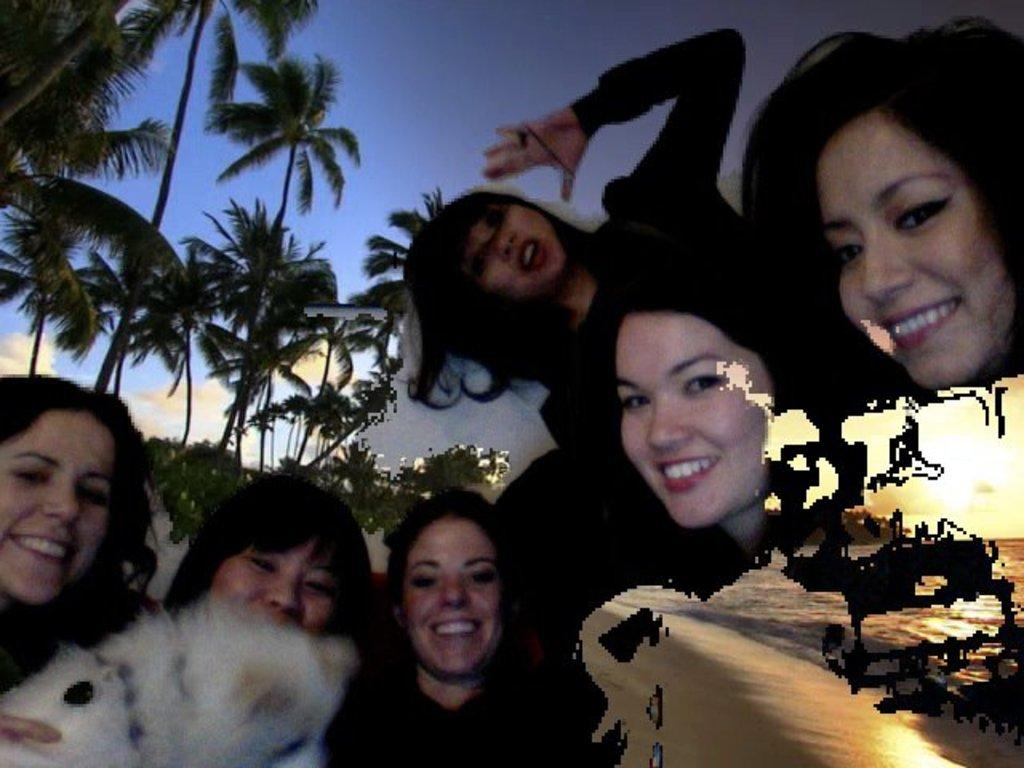What is happening in the image involving the group of people? The people in the image are smiling, suggesting they are enjoying themselves. Can you describe the environment in which the group of people is located? There is water visible at the bottom right side of the image, and there are trees and the sky visible in the background. What might be the reason for the group of people to be in this environment? The presence of water and trees suggests that they might be at a park, beach, or other outdoor recreational area. What type of celery is being used as fuel for the boat in the image? There is no boat or celery present in the image; it features a group of people in an outdoor environment. How many boys are visible in the image? The provided facts do not mention the gender of the people in the image, so it is impossible to determine the number of boys. 